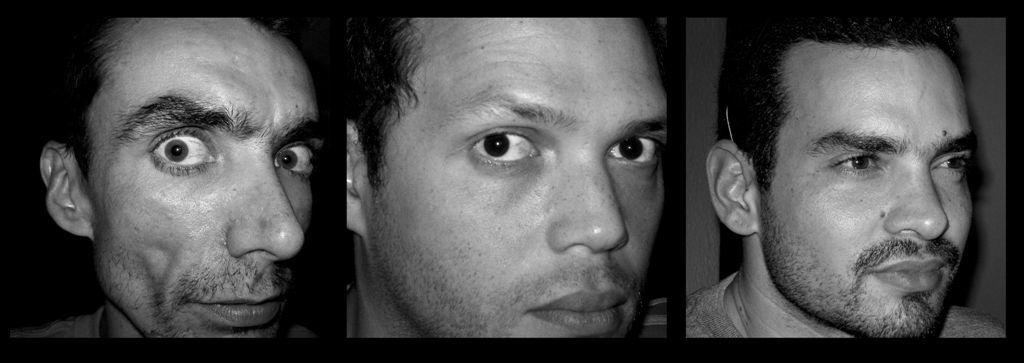What type of image is being described? The image is a collage. How many faces of men can be seen in the image? There are faces of three men in the image. What color scheme is used in the image? The image is black and white in color. What type of stem can be seen growing from the faces of the men in the image? There are no stems present in the image; it features faces of three men in a black and white collage. 